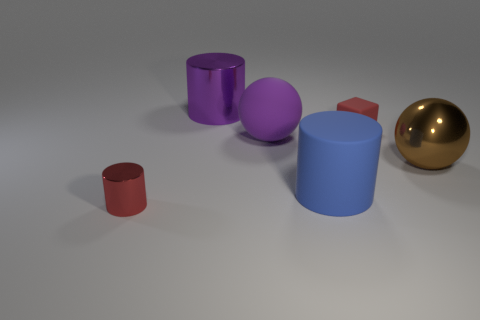Subtract all shiny cylinders. How many cylinders are left? 1 Subtract all balls. How many objects are left? 4 Add 1 tiny red metallic cylinders. How many objects exist? 7 Subtract 2 cylinders. How many cylinders are left? 1 Subtract all blue cylinders. How many cylinders are left? 2 Subtract 1 purple cylinders. How many objects are left? 5 Subtract all yellow spheres. Subtract all red cylinders. How many spheres are left? 2 Subtract all green cubes. How many yellow spheres are left? 0 Subtract all tiny balls. Subtract all large metallic things. How many objects are left? 4 Add 3 rubber blocks. How many rubber blocks are left? 4 